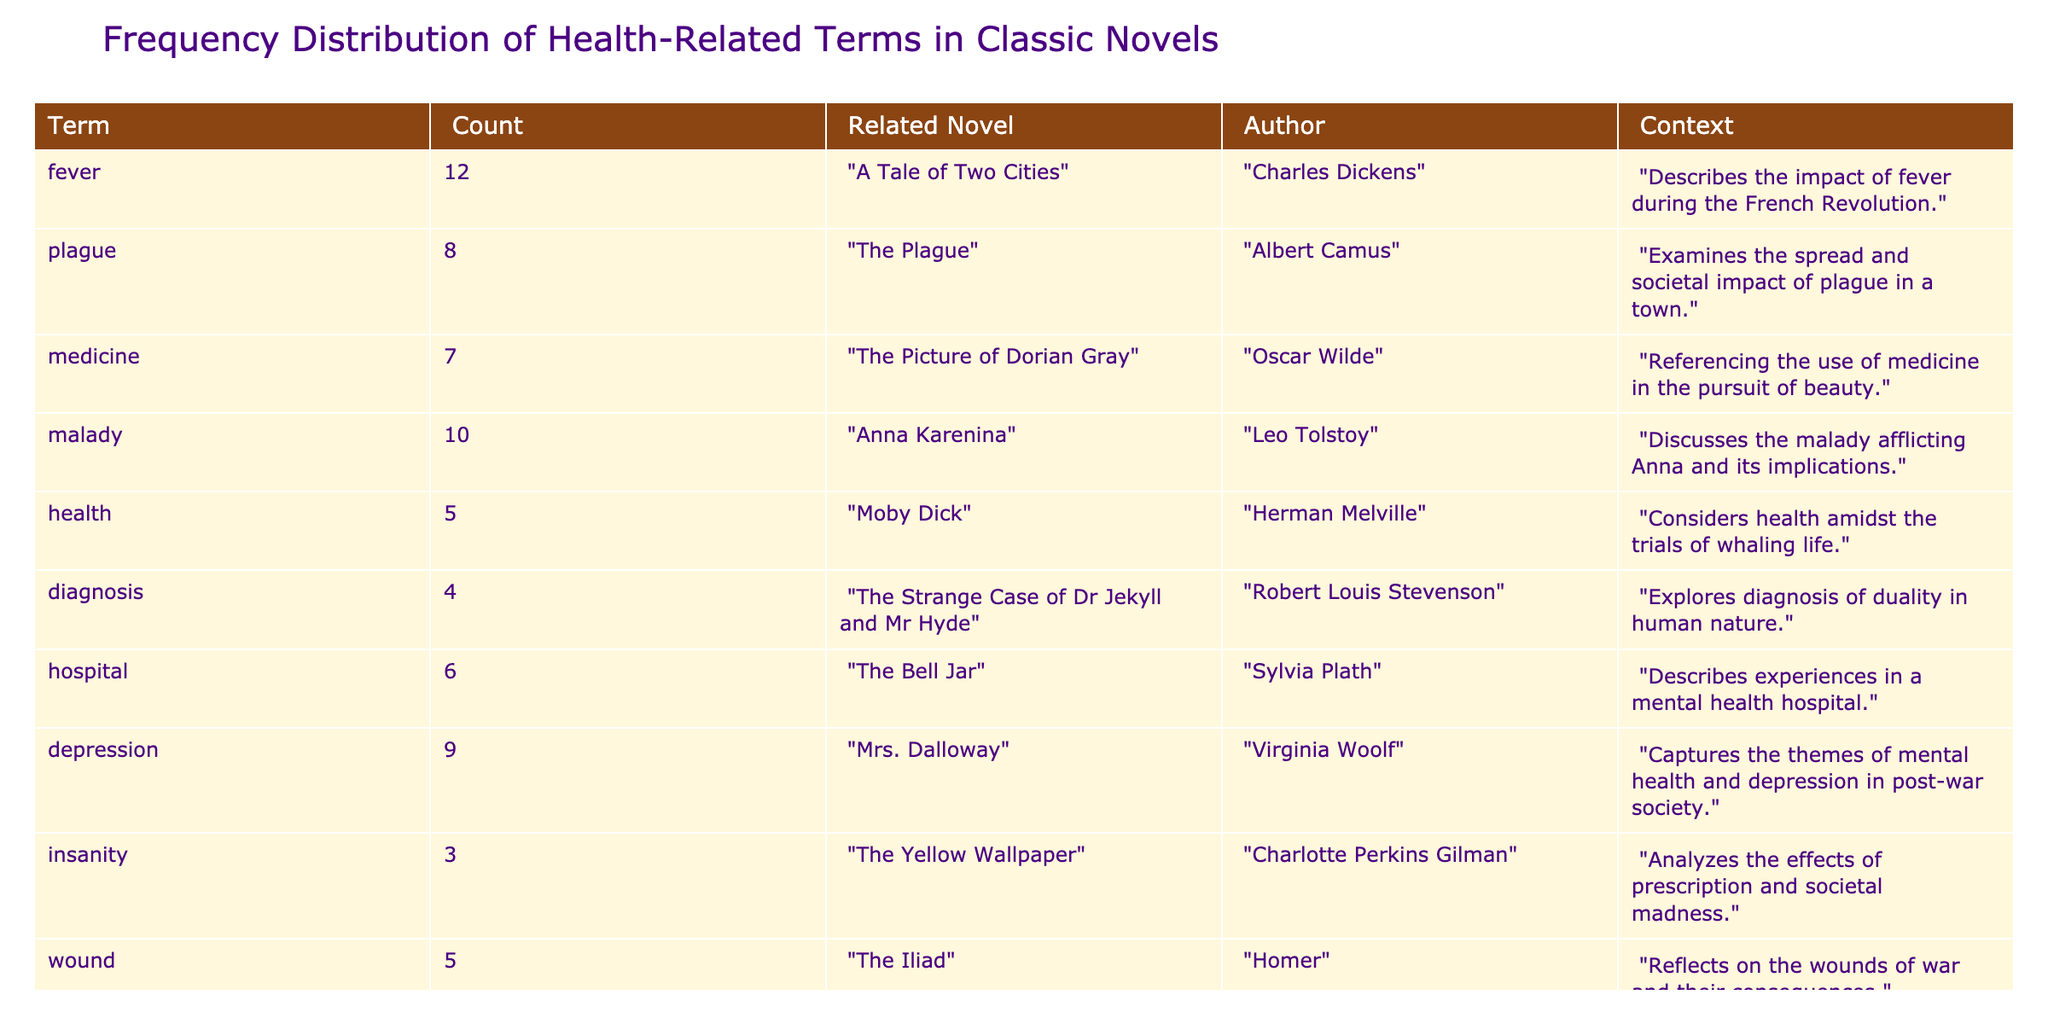What is the term with the highest count? The data shows the counts for various health-related terms. By examining the "Count" column, "fever" has the highest count at 12.
Answer: fever How many terms are associated with the novel "The Bell Jar"? The table indicates the term "hospital" is associated with "The Bell Jar". Thus, there is one term associated with this novel.
Answer: 1 What is the average count of health-related terms across the novels listed? To find the average, sum all the counts: 12 + 8 + 7 + 10 + 5 + 4 + 6 + 9 + 3 + 5 = 69. There are 10 terms, so the average is 69 / 10 = 6.9.
Answer: 6.9 Which term appears in the most novels, and how many novels feature it? By inspecting the related novels for each term, "fever" appears in one novel, "The Plague" in one novel, etc. Each term appears in only one novel; therefore, all terms share this characteristic.
Answer: 1 Is there a term related to mental health that has a count higher than 6? Reviewing the terms related to mental health, the term "depression" has a count of 9, which is higher than 6.
Answer: Yes What is the difference in count between "malady" and "hospital"? The count for "malady" is 10 and for "hospital" is 6. The difference is 10 - 6 = 4.
Answer: 4 Which term has the lowest count, and what novel is it associated with? Checking the "Count" column, "insanity" has the lowest count of 3. It is associated with "The Yellow Wallpaper".
Answer: insanity, The Yellow Wallpaper How many terms are related to novels authored by female writers? The terms related to female writers are "hospital" (The Bell Jar) and "insanity" (The Yellow Wallpaper), giving us a total of two terms.
Answer: 2 What percentage of the total counts does the term "plague" represent? The total count is 69, and "plague" has a count of 8. To find the percentage: (8 / 69) * 100 ≈ 11.6%.
Answer: 11.6% 